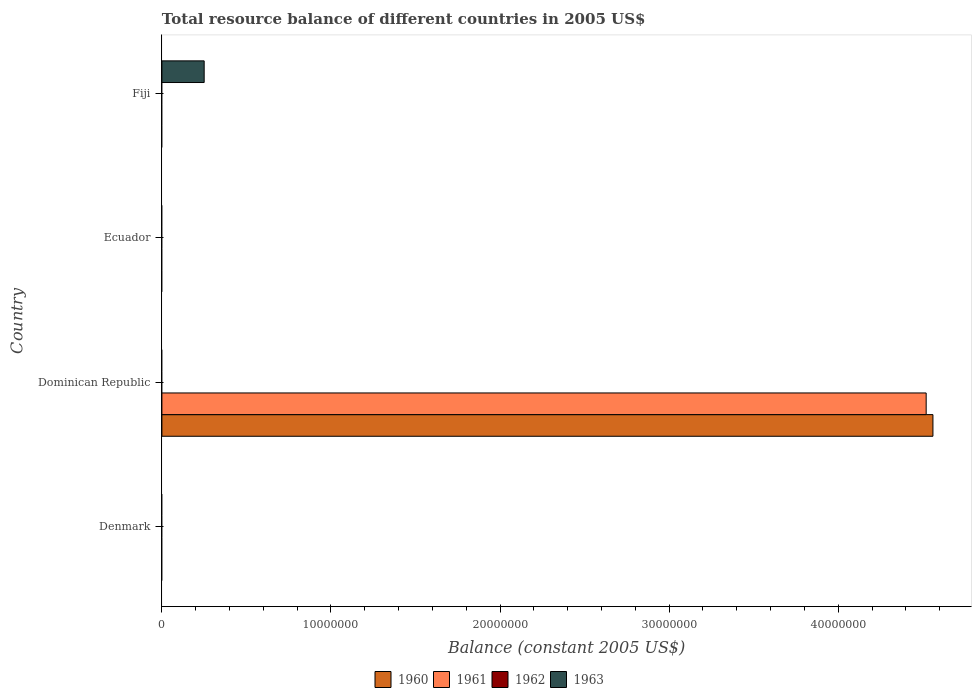What is the label of the 2nd group of bars from the top?
Ensure brevity in your answer.  Ecuador. Across all countries, what is the maximum total resource balance in 1960?
Provide a succinct answer. 4.56e+07. Across all countries, what is the minimum total resource balance in 1962?
Offer a very short reply. 0. In which country was the total resource balance in 1961 maximum?
Provide a succinct answer. Dominican Republic. What is the total total resource balance in 1963 in the graph?
Ensure brevity in your answer.  2.50e+06. What is the difference between the total resource balance in 1961 in Fiji and the total resource balance in 1963 in Denmark?
Ensure brevity in your answer.  0. What is the average total resource balance in 1962 per country?
Offer a very short reply. 0. In how many countries, is the total resource balance in 1960 greater than 10000000 US$?
Keep it short and to the point. 1. What is the difference between the highest and the lowest total resource balance in 1961?
Give a very brief answer. 4.52e+07. In how many countries, is the total resource balance in 1961 greater than the average total resource balance in 1961 taken over all countries?
Ensure brevity in your answer.  1. Is it the case that in every country, the sum of the total resource balance in 1963 and total resource balance in 1960 is greater than the sum of total resource balance in 1961 and total resource balance in 1962?
Give a very brief answer. No. How many bars are there?
Your answer should be very brief. 3. Are all the bars in the graph horizontal?
Your answer should be compact. Yes. How many countries are there in the graph?
Make the answer very short. 4. Does the graph contain grids?
Offer a terse response. No. What is the title of the graph?
Provide a succinct answer. Total resource balance of different countries in 2005 US$. Does "1976" appear as one of the legend labels in the graph?
Your answer should be compact. No. What is the label or title of the X-axis?
Your response must be concise. Balance (constant 2005 US$). What is the label or title of the Y-axis?
Your answer should be very brief. Country. What is the Balance (constant 2005 US$) in 1960 in Denmark?
Provide a short and direct response. 0. What is the Balance (constant 2005 US$) of 1961 in Denmark?
Provide a succinct answer. 0. What is the Balance (constant 2005 US$) of 1963 in Denmark?
Offer a very short reply. 0. What is the Balance (constant 2005 US$) of 1960 in Dominican Republic?
Give a very brief answer. 4.56e+07. What is the Balance (constant 2005 US$) in 1961 in Dominican Republic?
Your answer should be compact. 4.52e+07. What is the Balance (constant 2005 US$) of 1960 in Ecuador?
Your answer should be very brief. 0. What is the Balance (constant 2005 US$) in 1963 in Ecuador?
Your response must be concise. 0. What is the Balance (constant 2005 US$) of 1960 in Fiji?
Give a very brief answer. 0. What is the Balance (constant 2005 US$) of 1961 in Fiji?
Your answer should be very brief. 0. What is the Balance (constant 2005 US$) in 1963 in Fiji?
Offer a very short reply. 2.50e+06. Across all countries, what is the maximum Balance (constant 2005 US$) of 1960?
Your answer should be compact. 4.56e+07. Across all countries, what is the maximum Balance (constant 2005 US$) of 1961?
Provide a succinct answer. 4.52e+07. Across all countries, what is the maximum Balance (constant 2005 US$) in 1963?
Provide a succinct answer. 2.50e+06. Across all countries, what is the minimum Balance (constant 2005 US$) of 1960?
Your response must be concise. 0. What is the total Balance (constant 2005 US$) of 1960 in the graph?
Ensure brevity in your answer.  4.56e+07. What is the total Balance (constant 2005 US$) of 1961 in the graph?
Offer a very short reply. 4.52e+07. What is the total Balance (constant 2005 US$) in 1963 in the graph?
Keep it short and to the point. 2.50e+06. What is the difference between the Balance (constant 2005 US$) of 1960 in Dominican Republic and the Balance (constant 2005 US$) of 1963 in Fiji?
Your answer should be compact. 4.31e+07. What is the difference between the Balance (constant 2005 US$) in 1961 in Dominican Republic and the Balance (constant 2005 US$) in 1963 in Fiji?
Give a very brief answer. 4.27e+07. What is the average Balance (constant 2005 US$) in 1960 per country?
Make the answer very short. 1.14e+07. What is the average Balance (constant 2005 US$) in 1961 per country?
Make the answer very short. 1.13e+07. What is the average Balance (constant 2005 US$) of 1962 per country?
Make the answer very short. 0. What is the average Balance (constant 2005 US$) in 1963 per country?
Offer a terse response. 6.25e+05. What is the difference between the highest and the lowest Balance (constant 2005 US$) in 1960?
Your answer should be very brief. 4.56e+07. What is the difference between the highest and the lowest Balance (constant 2005 US$) of 1961?
Ensure brevity in your answer.  4.52e+07. What is the difference between the highest and the lowest Balance (constant 2005 US$) in 1963?
Give a very brief answer. 2.50e+06. 